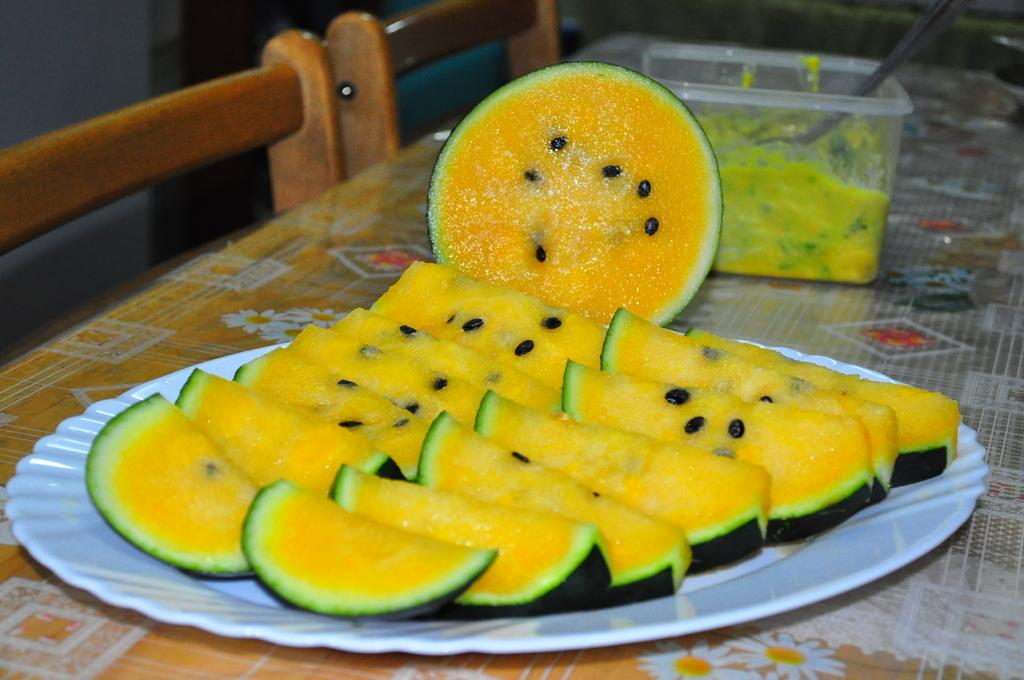What is on the plate in the image? There are food items in a plate in the image. What else can be seen on the table in the image? There is a box on the table in the image. What type of furniture is visible in the image? There are chairs in the image. What type of canvas is being used by the hen in the image? There is no canvas or hen present in the image. 